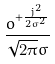Convert formula to latex. <formula><loc_0><loc_0><loc_500><loc_500>\frac { o ^ { + \frac { j ^ { 2 } } { 2 \sigma ^ { 2 } } } } { \sqrt { 2 \pi } \sigma }</formula> 